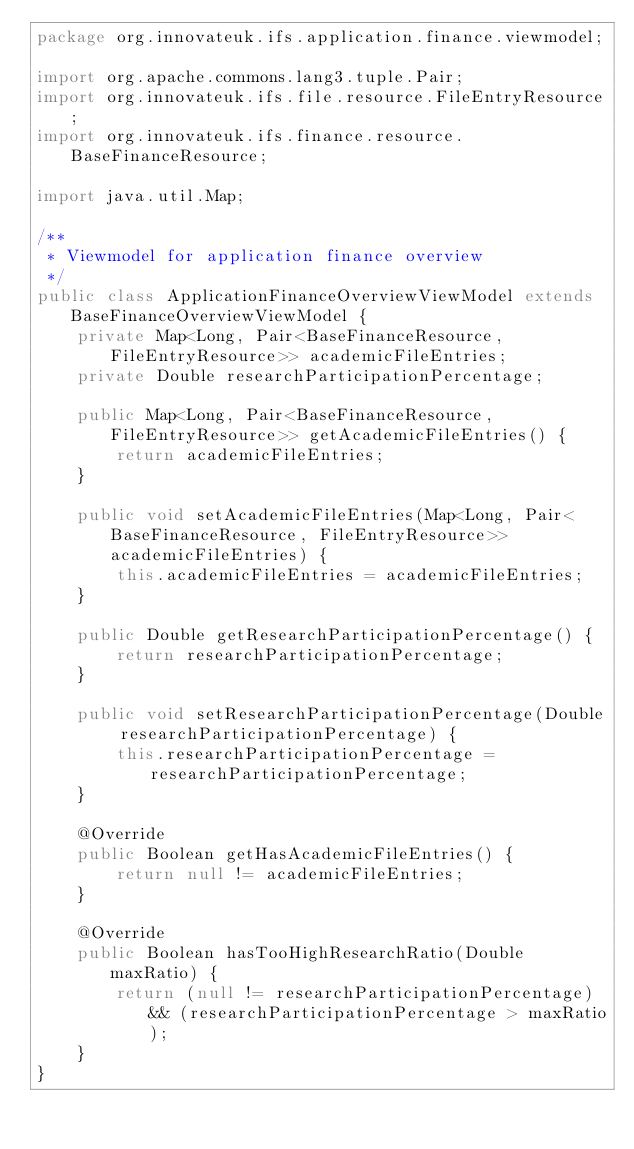Convert code to text. <code><loc_0><loc_0><loc_500><loc_500><_Java_>package org.innovateuk.ifs.application.finance.viewmodel;

import org.apache.commons.lang3.tuple.Pair;
import org.innovateuk.ifs.file.resource.FileEntryResource;
import org.innovateuk.ifs.finance.resource.BaseFinanceResource;

import java.util.Map;

/**
 * Viewmodel for application finance overview
 */
public class ApplicationFinanceOverviewViewModel extends BaseFinanceOverviewViewModel {
    private Map<Long, Pair<BaseFinanceResource, FileEntryResource>> academicFileEntries;
    private Double researchParticipationPercentage;

    public Map<Long, Pair<BaseFinanceResource, FileEntryResource>> getAcademicFileEntries() {
        return academicFileEntries;
    }

    public void setAcademicFileEntries(Map<Long, Pair<BaseFinanceResource, FileEntryResource>> academicFileEntries) {
        this.academicFileEntries = academicFileEntries;
    }

    public Double getResearchParticipationPercentage() {
        return researchParticipationPercentage;
    }

    public void setResearchParticipationPercentage(Double researchParticipationPercentage) {
        this.researchParticipationPercentage = researchParticipationPercentage;
    }

    @Override
    public Boolean getHasAcademicFileEntries() {
        return null != academicFileEntries;
    }

    @Override
    public Boolean hasTooHighResearchRatio(Double maxRatio) {
        return (null != researchParticipationPercentage) && (researchParticipationPercentage > maxRatio);
    }
}
</code> 